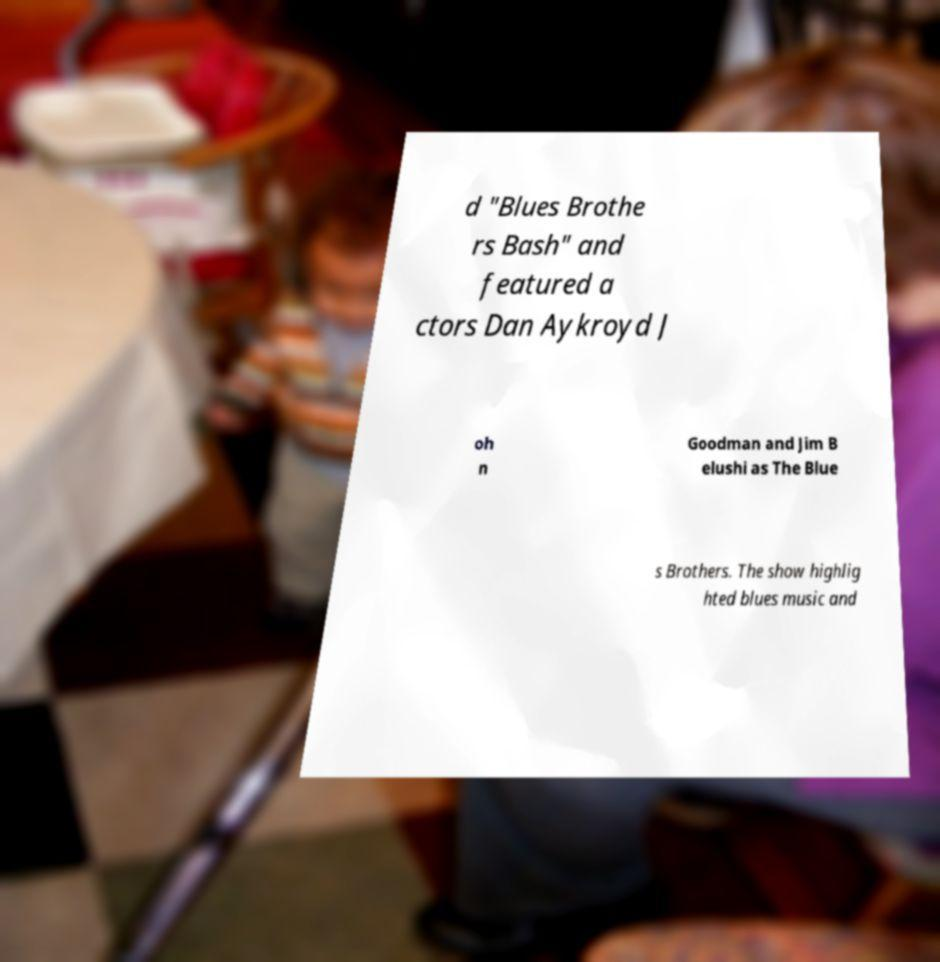What messages or text are displayed in this image? I need them in a readable, typed format. d "Blues Brothe rs Bash" and featured a ctors Dan Aykroyd J oh n Goodman and Jim B elushi as The Blue s Brothers. The show highlig hted blues music and 